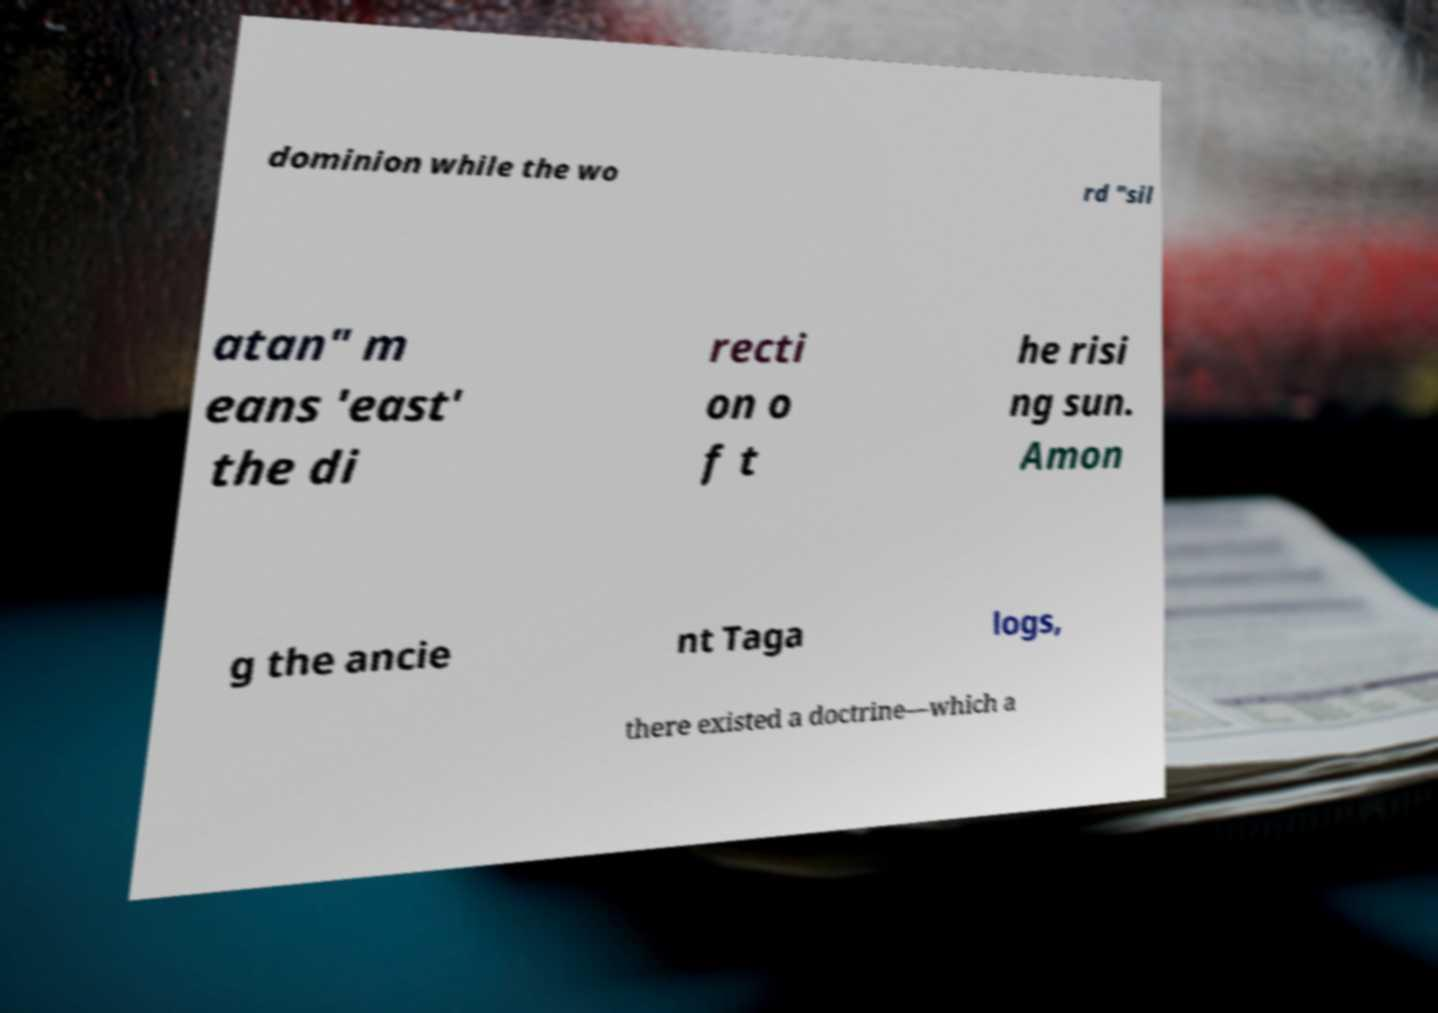For documentation purposes, I need the text within this image transcribed. Could you provide that? dominion while the wo rd "sil atan" m eans 'east' the di recti on o f t he risi ng sun. Amon g the ancie nt Taga logs, there existed a doctrine—which a 